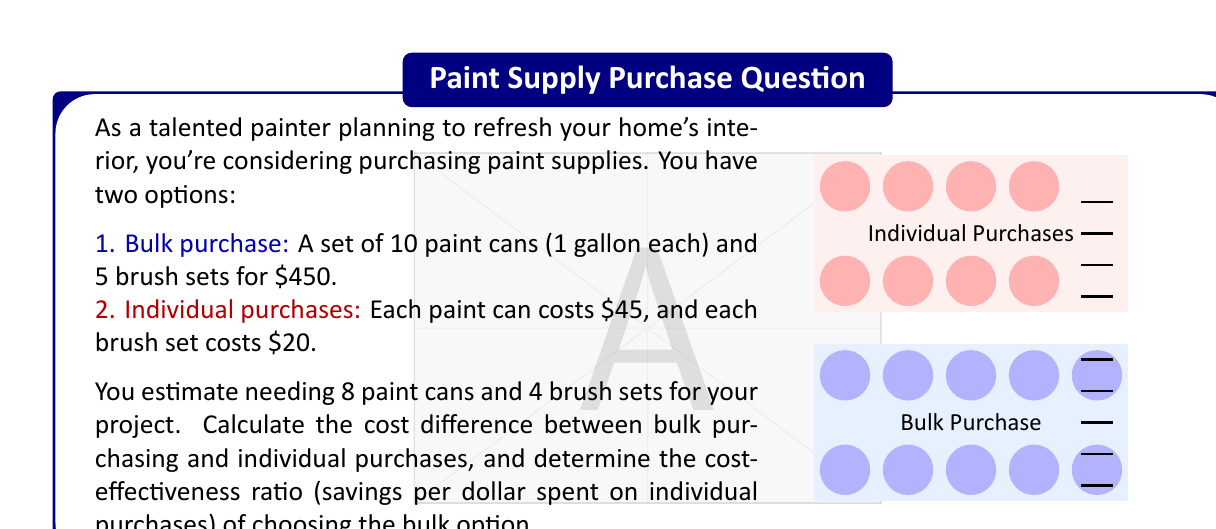Can you solve this math problem? Let's approach this problem step-by-step:

1) First, calculate the cost of individual purchases:
   - 8 paint cans: $8 \times $45 = $360
   - 4 brush sets: $4 \times $20 = $80
   Total cost of individual purchases: $360 + $80 = $440

2) The bulk purchase costs $450 for 10 paint cans and 5 brush sets.

3) Calculate the cost difference:
   Cost difference = Individual purchase cost - Bulk purchase cost
   $$ \text{Cost difference} = $440 - $450 = -$10 $$

   The negative value indicates that the bulk purchase is actually $10 more expensive.

4) To calculate the cost-effectiveness ratio, we use:
   $$ \text{Cost-effectiveness ratio} = \frac{\text{Savings}}{\text{Cost of individual purchases}} $$

   In this case, there are no savings, but rather an additional cost. We'll use the absolute value of the difference to calculate the ratio:

   $$ \text{Cost-effectiveness ratio} = \frac{|-$10|}{$440} = \frac{10}{440} \approx 0.0227 $$

5) This ratio can be interpreted as an additional cost of about 2.27 cents per dollar spent on individual purchases.
Answer: Cost difference: -$10; Cost-effectiveness ratio: 0.0227 (additional cost) 